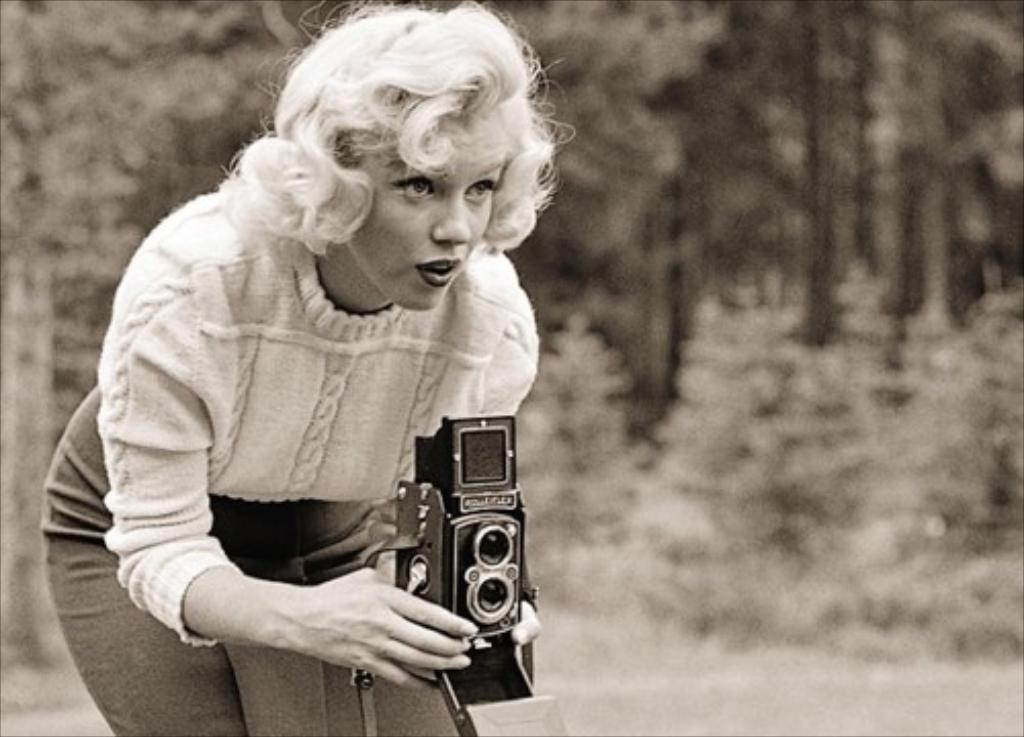Who is the main subject in the image? There is a woman in the image. What is the woman doing in the image? The woman is standing and taking a picture with a camera. What can be seen in the background of the image? There are trees in the background of the image. Reasoning: Let' Let's think step by step in order to produce the conversation. We start by identifying the main subject in the image, which is the woman. Then, we describe what the woman is doing, which is standing and taking a picture with a camera. Finally, we mention the background of the image, which includes trees. Each question is designed to elicit a specific detail about the image that is known from the provided facts. Absurd Question/Answer: How many spiders are crawling on the woman's camera in the image? There are no spiders visible in the image, so it is not possible to determine how many might be on the camera. 